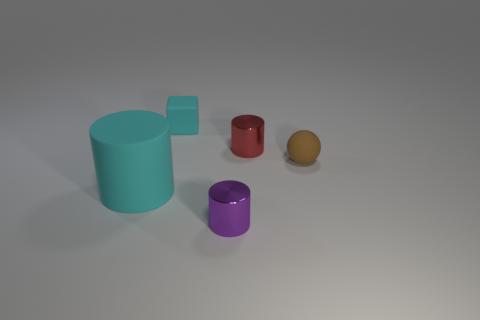Subtract all tiny shiny cylinders. How many cylinders are left? 1 Add 3 cyan rubber blocks. How many objects exist? 8 Subtract all cubes. How many objects are left? 4 Add 1 purple objects. How many purple objects exist? 2 Subtract 1 purple cylinders. How many objects are left? 4 Subtract all cyan cubes. Subtract all green metal things. How many objects are left? 4 Add 5 cyan objects. How many cyan objects are left? 7 